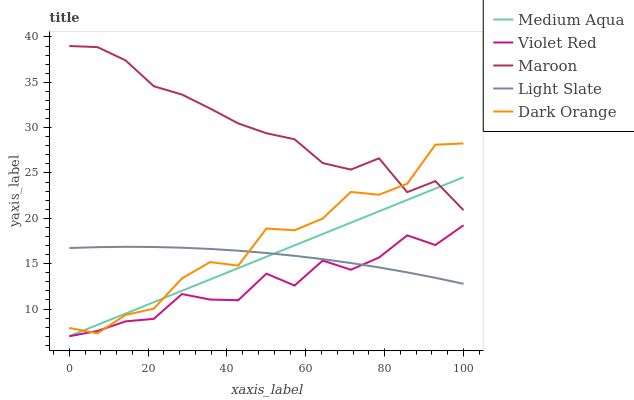Does Violet Red have the minimum area under the curve?
Answer yes or no. Yes. Does Maroon have the maximum area under the curve?
Answer yes or no. Yes. Does Dark Orange have the minimum area under the curve?
Answer yes or no. No. Does Dark Orange have the maximum area under the curve?
Answer yes or no. No. Is Medium Aqua the smoothest?
Answer yes or no. Yes. Is Dark Orange the roughest?
Answer yes or no. Yes. Is Violet Red the smoothest?
Answer yes or no. No. Is Violet Red the roughest?
Answer yes or no. No. Does Violet Red have the lowest value?
Answer yes or no. Yes. Does Dark Orange have the lowest value?
Answer yes or no. No. Does Maroon have the highest value?
Answer yes or no. Yes. Does Dark Orange have the highest value?
Answer yes or no. No. Is Light Slate less than Maroon?
Answer yes or no. Yes. Is Maroon greater than Violet Red?
Answer yes or no. Yes. Does Maroon intersect Dark Orange?
Answer yes or no. Yes. Is Maroon less than Dark Orange?
Answer yes or no. No. Is Maroon greater than Dark Orange?
Answer yes or no. No. Does Light Slate intersect Maroon?
Answer yes or no. No. 